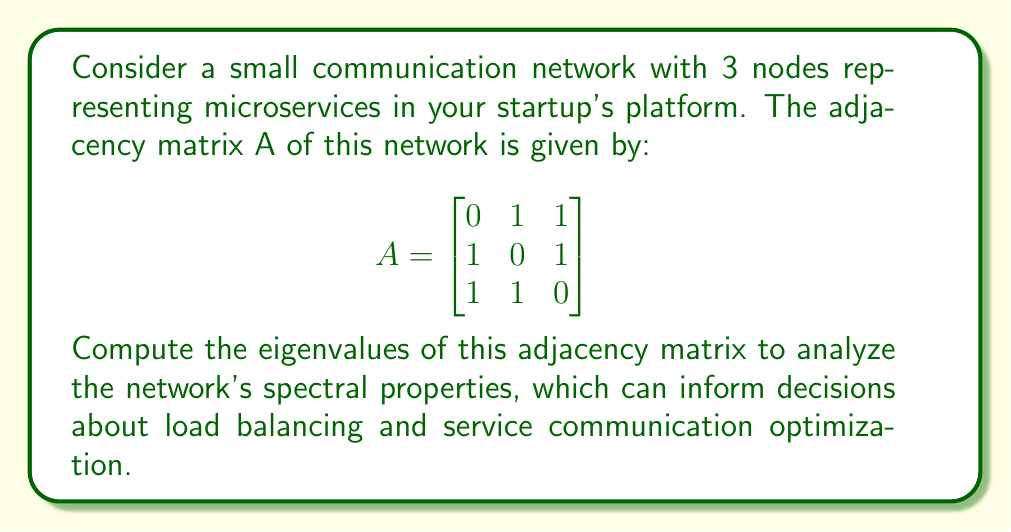Could you help me with this problem? To find the eigenvalues of the adjacency matrix A, we need to solve the characteristic equation:

$$\det(A - \lambda I) = 0$$

Where $I$ is the 3x3 identity matrix and $\lambda$ represents the eigenvalues.

Step 1: Set up the characteristic equation:
$$\begin{vmatrix}
-\lambda & 1 & 1 \\
1 & -\lambda & 1 \\
1 & 1 & -\lambda
\end{vmatrix} = 0$$

Step 2: Expand the determinant:
$$-\lambda^3 + 3\lambda + 2 = 0$$

Step 3: Factor the equation:
$$-(\lambda + 2)(\lambda - 1)^2 = 0$$

Step 4: Solve for $\lambda$:
$\lambda = -2$ or $\lambda = 1$ (with algebraic multiplicity 2)

Therefore, the eigenvalues of the adjacency matrix are:
$\lambda_1 = -2$, $\lambda_2 = 1$, and $\lambda_3 = 1$
Answer: $\lambda_1 = -2$, $\lambda_2 = \lambda_3 = 1$ 